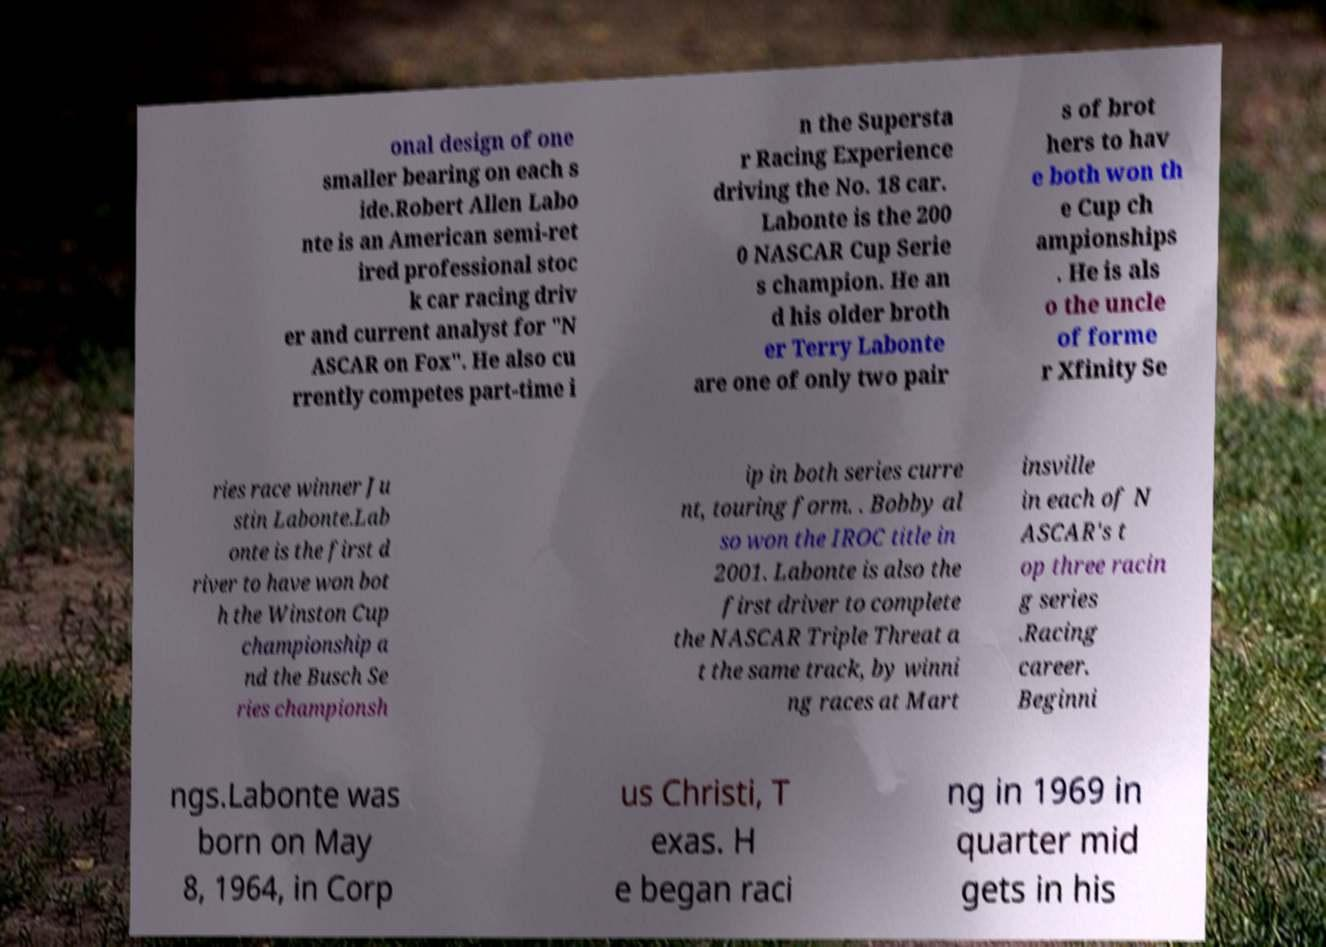Could you assist in decoding the text presented in this image and type it out clearly? onal design of one smaller bearing on each s ide.Robert Allen Labo nte is an American semi-ret ired professional stoc k car racing driv er and current analyst for "N ASCAR on Fox". He also cu rrently competes part-time i n the Supersta r Racing Experience driving the No. 18 car. Labonte is the 200 0 NASCAR Cup Serie s champion. He an d his older broth er Terry Labonte are one of only two pair s of brot hers to hav e both won th e Cup ch ampionships . He is als o the uncle of forme r Xfinity Se ries race winner Ju stin Labonte.Lab onte is the first d river to have won bot h the Winston Cup championship a nd the Busch Se ries championsh ip in both series curre nt, touring form. . Bobby al so won the IROC title in 2001. Labonte is also the first driver to complete the NASCAR Triple Threat a t the same track, by winni ng races at Mart insville in each of N ASCAR's t op three racin g series .Racing career. Beginni ngs.Labonte was born on May 8, 1964, in Corp us Christi, T exas. H e began raci ng in 1969 in quarter mid gets in his 